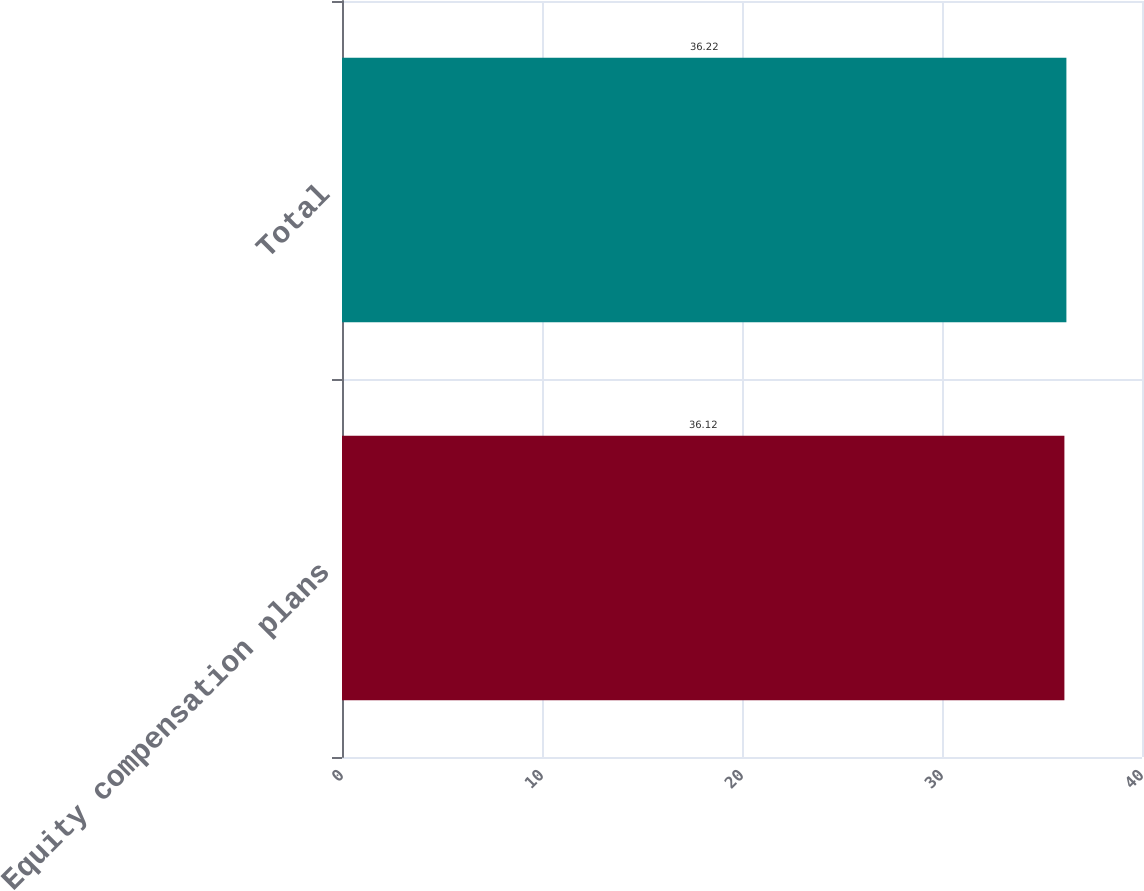Convert chart to OTSL. <chart><loc_0><loc_0><loc_500><loc_500><bar_chart><fcel>Equity compensation plans<fcel>Total<nl><fcel>36.12<fcel>36.22<nl></chart> 